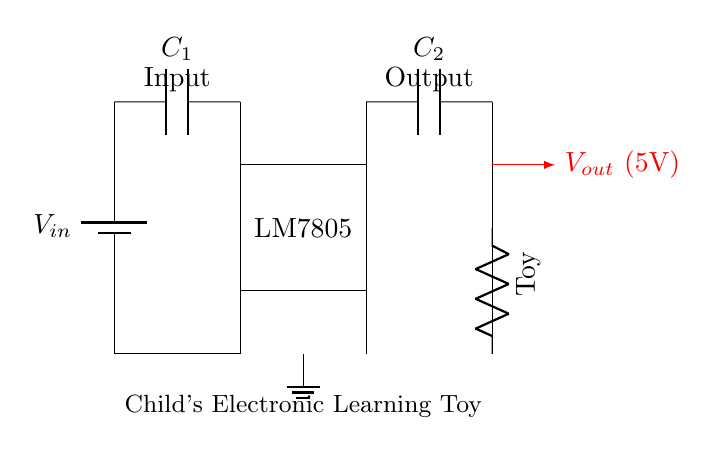What is the function of the LM7805? The LM7805 is a voltage regulator that provides a stable output voltage of 5V, making it suitable for the toy's operation.
Answer: Voltage regulator What is the input voltage represented by \(V_{in}\)? The input voltage \(V_{in}\) is required to be greater than 5V to properly regulate down to the 5V output; the exact value is not specified in the diagram but should be typical battery voltage levels.
Answer: Greater than 5V What are the values of the capacitors \(C_1\) and \(C_2\)? The capacitor values are not specified in the diagram, but they are typically chosen to stabilize input and output voltages. Common values could be 10µF for \(C_1\) and 10µF for \(C_2\), though actual values depend on the toy's specific design.
Answer: Not specified How does the output voltage connect to the load? The output voltage connects directly from the output of the voltage regulator (LM7805) to the load represented by the toy, ensuring it receives a stable power supply.
Answer: Directly What component is used as a load in this circuit? The load in this circuit is represented by a resistor labeled "Toy," which simulates the electronic learning toy consuming power from the circuit.
Answer: Toy What type of circuit is represented here? This circuit is a linear voltage regulator circuit, as it employs the LM7805 to step down a higher voltage to a stable lower voltage.
Answer: Linear voltage regulator 